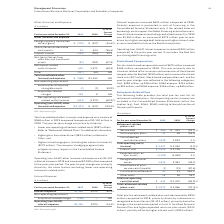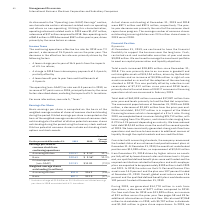According to International Business Machines's financial document, What caused the Total pre-tax retirement-related plan cost to decrease? driven by a decrease in recognized actuarial losses ($1,123 million), primarily due to the change in the amortization period in the U.S. Qualified Personal Pension. The document states: "eased by $994 million compared to 2018, primarily driven by a decrease in recognized actuarial losses ($1,123 million), primarily due to the change in..." Also, What caused the Non-operating costs to decrease? As discussed in the “Operating (non-GAAP) Earnings” section, we characterize certain retirement-related costs as operating and others as non-operating. Utilizing this characterization, operating retirement-related costs in 2019 were $1,457 million, a decrease of $37 million compared to 2018. Non-operating costs of $615 million in 2019 decreased $957 million year to year, driven primarily by the same factors as above.. The document states: "As discussed in the “Operating (non-GAAP) Earnings” section, we characterize certain retirement-related costs as operating and others as non-operating..." Also, What were the operating retirement related costs in 2019? According to the financial document, $1,457 million. The relevant text states: "n, operating retirement-related costs in 2019 were $1,457 million, a decrease of $37 million compared to 2018. Non-operating costs of $615 million in 2019 decreased..." Also, can you calculate: What was the increase / (decrease) in service cost from 2018 to 2019? Based on the calculation: 385 - 431, the result is -46 (in millions). This is based on the information: "Service cost $ 385 $ 431 (10.7)% erating (non-GAAP) other (income) and expense $(1,431) $ (422) 239.4%..." The key data points involved are: 385, 431. Also, can you calculate: What was the average interest cost? To answer this question, I need to perform calculations using the financial data. The calculation is: (2,929 + 2,726) / 2, which equals 2827.5 (in millions). This is based on the information: "Interest cost $ 2,929 $ 2,726 7.4% Interest cost $ 2,929 $ 2,726 7.4%..." The key data points involved are: 2,726, 2,929. Also, can you calculate: What was the increase / (decrease) in the Other costs from 2018 to 2019? Based on the calculation: 28 - 16, the result is 12 (in millions). This is based on the information: "Other costs 28 16 76.2 Other costs 28 16 76.2..." The key data points involved are: 16, 28. 